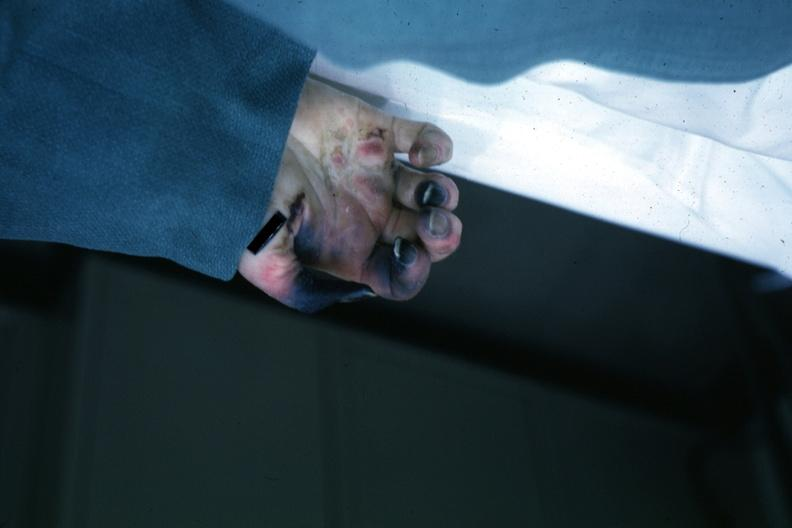what is present?
Answer the question using a single word or phrase. Gangrene fingers 